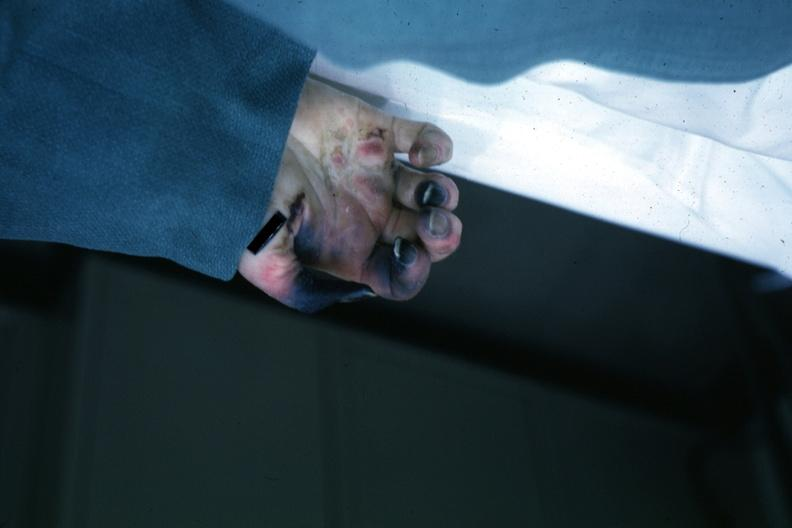what is present?
Answer the question using a single word or phrase. Gangrene fingers 